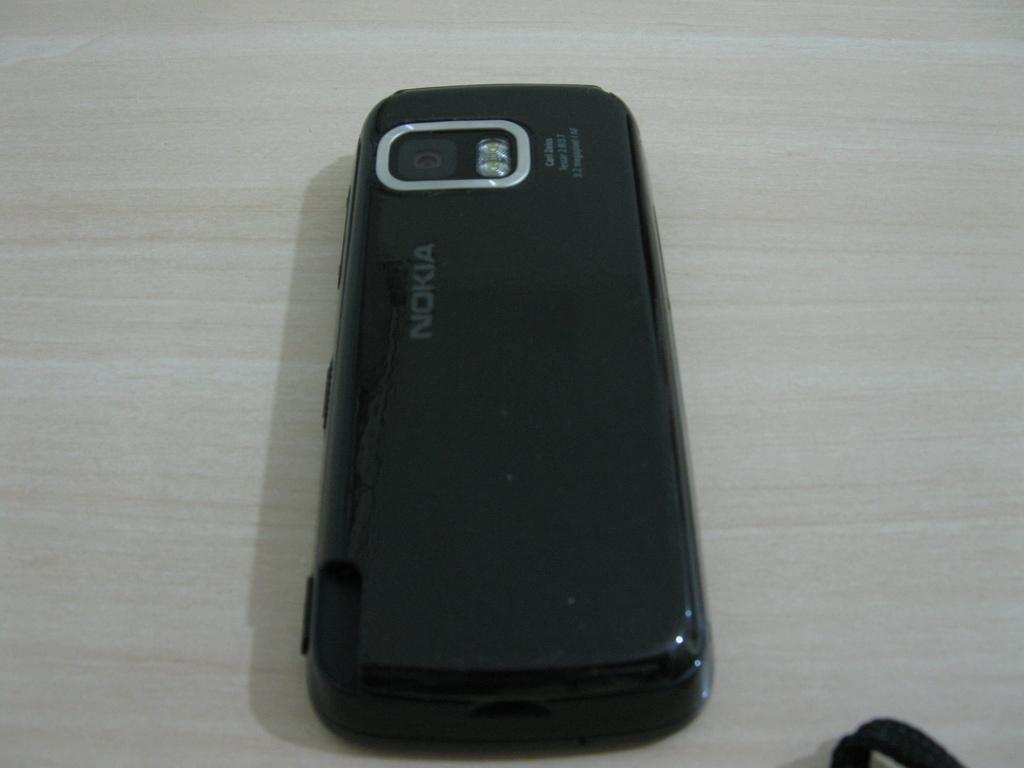<image>
Relay a brief, clear account of the picture shown. a black Nokia phone is laying on its front on the table 